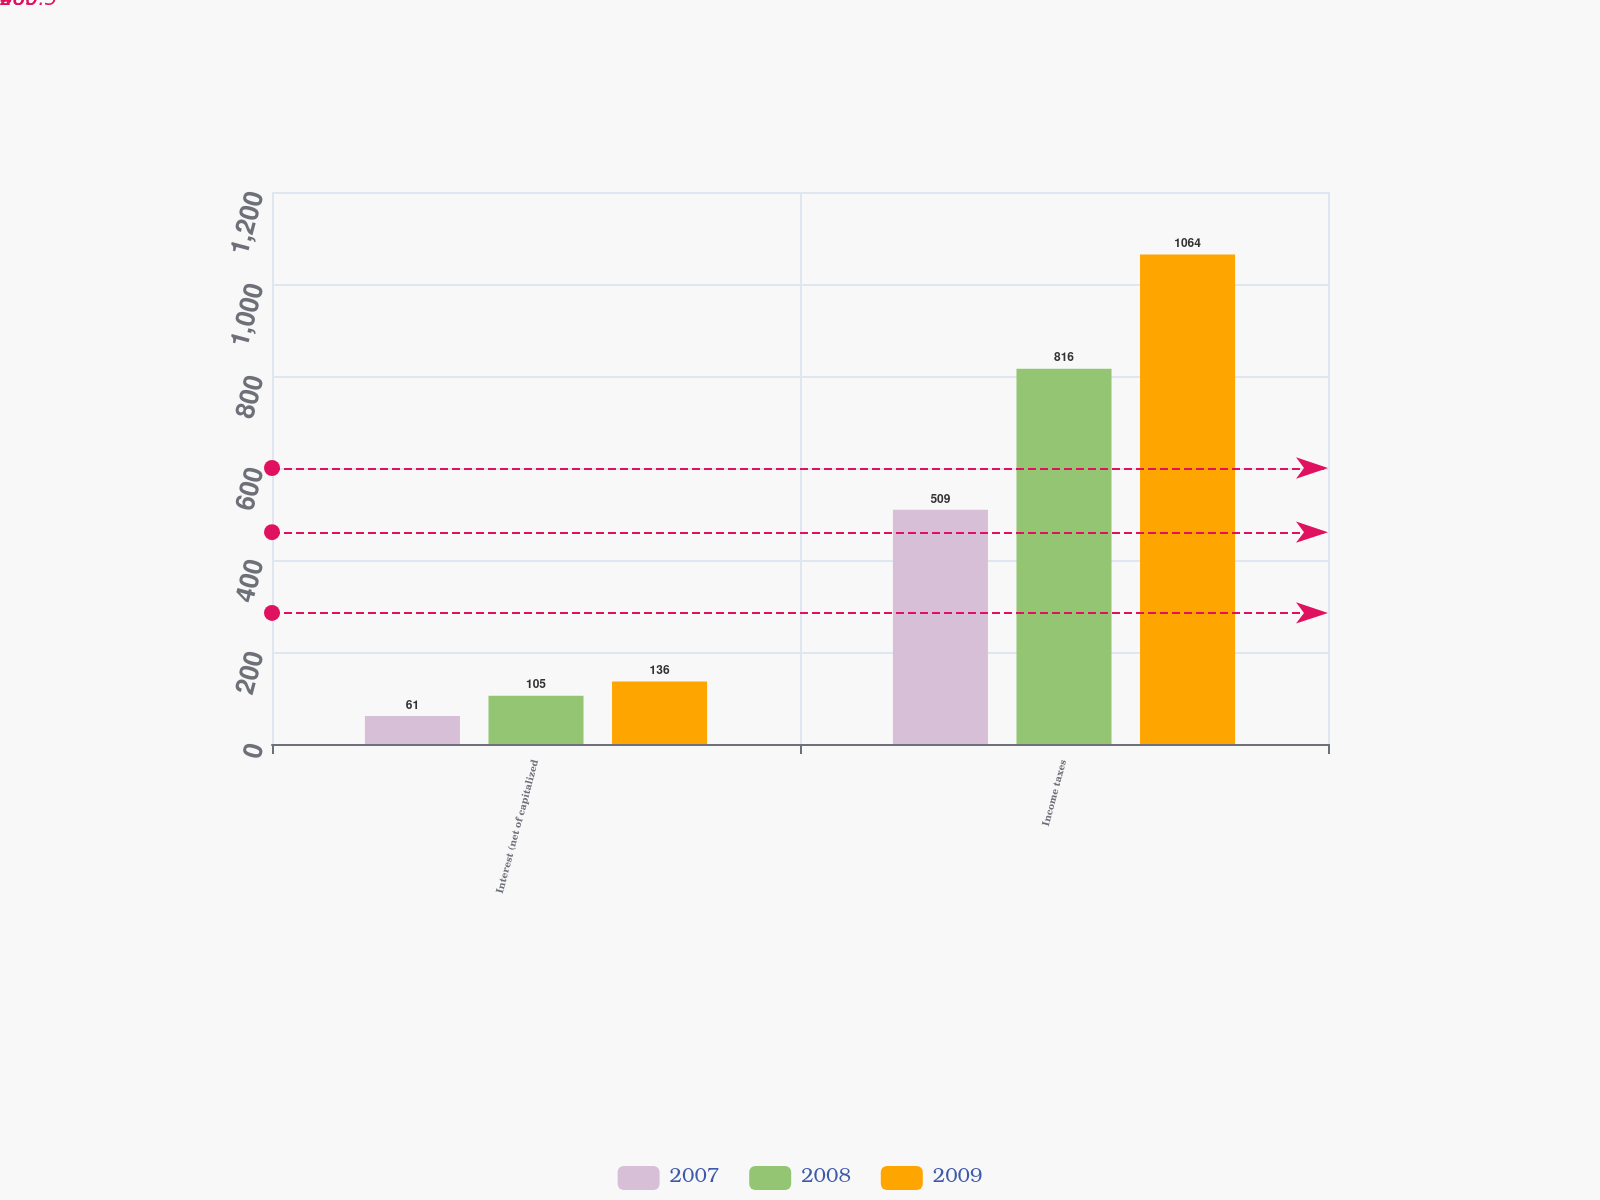<chart> <loc_0><loc_0><loc_500><loc_500><stacked_bar_chart><ecel><fcel>Interest (net of capitalized<fcel>Income taxes<nl><fcel>2007<fcel>61<fcel>509<nl><fcel>2008<fcel>105<fcel>816<nl><fcel>2009<fcel>136<fcel>1064<nl></chart> 